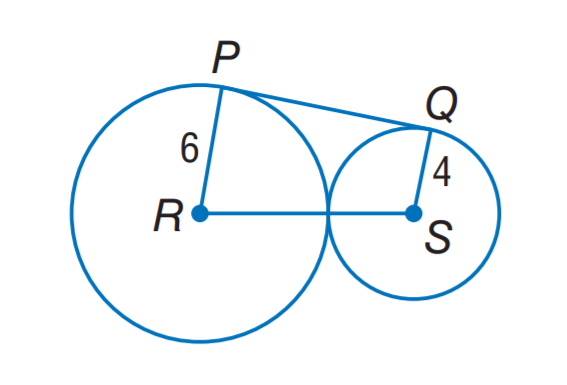Answer the mathemtical geometry problem and directly provide the correct option letter.
Question: P Q is tangent to circles R and S. Find P Q.
Choices: A: 4 \sqrt 2 B: 6 \sqrt 2 C: 4 \sqrt 6 D: 6 \sqrt 6 C 